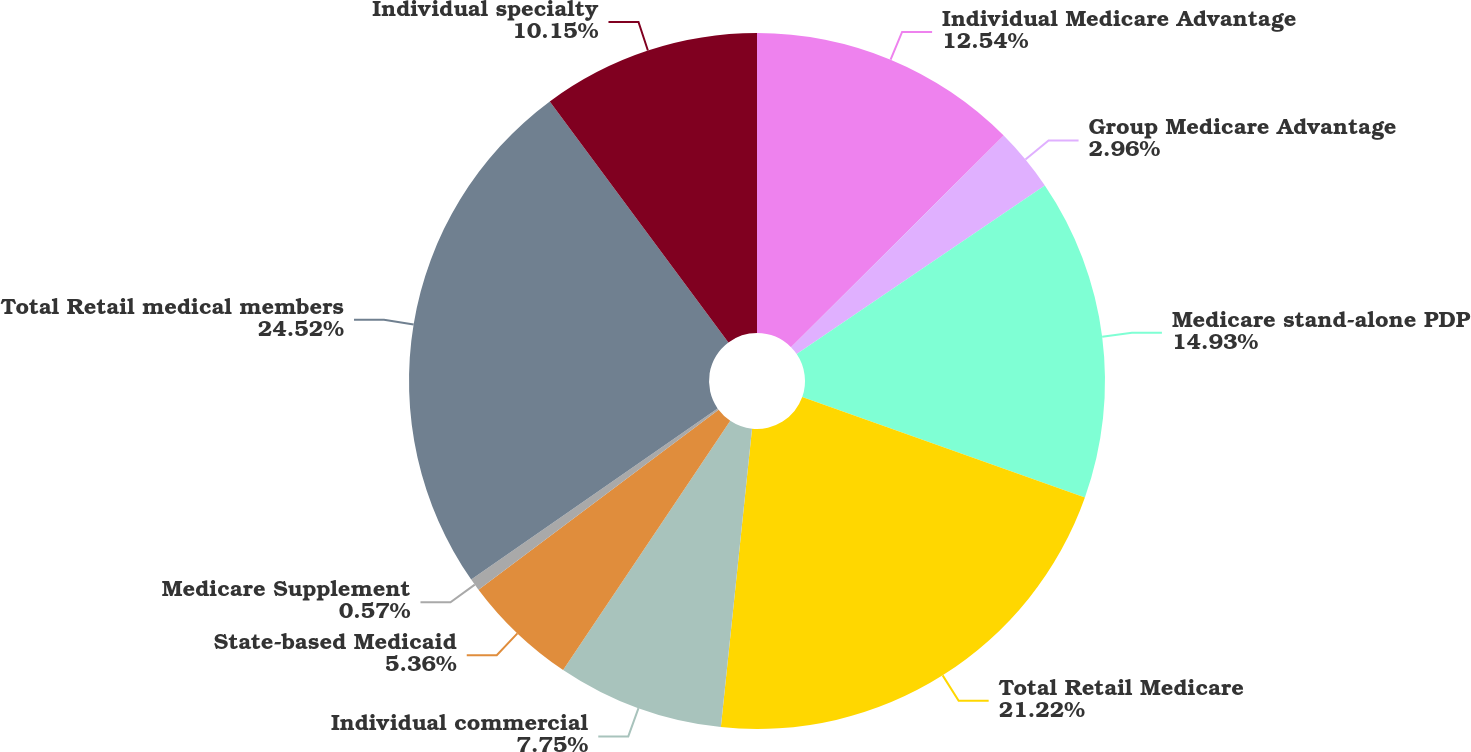<chart> <loc_0><loc_0><loc_500><loc_500><pie_chart><fcel>Individual Medicare Advantage<fcel>Group Medicare Advantage<fcel>Medicare stand-alone PDP<fcel>Total Retail Medicare<fcel>Individual commercial<fcel>State-based Medicaid<fcel>Medicare Supplement<fcel>Total Retail medical members<fcel>Individual specialty<nl><fcel>12.54%<fcel>2.96%<fcel>14.93%<fcel>21.22%<fcel>7.75%<fcel>5.36%<fcel>0.57%<fcel>24.51%<fcel>10.15%<nl></chart> 